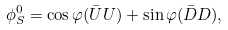Convert formula to latex. <formula><loc_0><loc_0><loc_500><loc_500>\phi _ { S } ^ { 0 } = \cos \varphi ( \bar { U } U ) + \sin \varphi ( \bar { D } D ) ,</formula> 